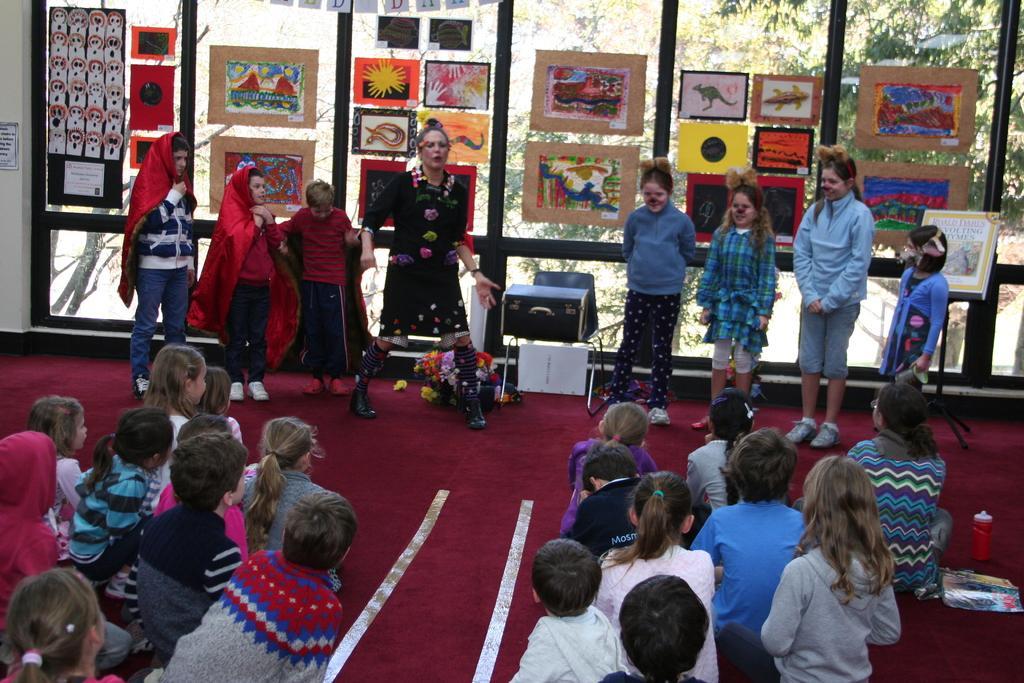Can you describe this image briefly? In this picture I can observe some children sitting on the floor. I can observe a woman standing in front of these children. There are some charts on the glasses. In the background there are trees. 